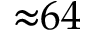Convert formula to latex. <formula><loc_0><loc_0><loc_500><loc_500>{ \approx } 6 4</formula> 